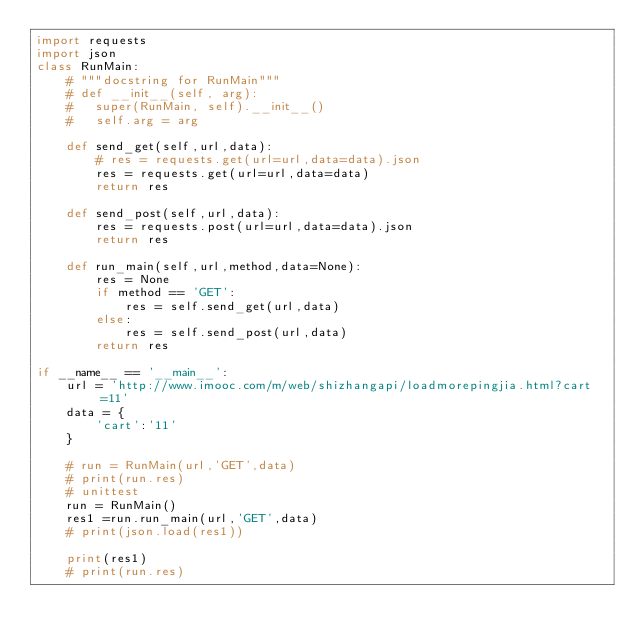Convert code to text. <code><loc_0><loc_0><loc_500><loc_500><_Python_>import requests
import json
class RunMain:
	# """docstring for RunMain"""
	# def __init__(self, arg):
	# 	super(RunMain, self).__init__()
	# 	self.arg = arg

	def send_get(self,url,data):
		# res = requests.get(url=url,data=data).json
		res = requests.get(url=url,data=data)
		return res

	def send_post(self,url,data):
		res = requests.post(url=url,data=data).json
		return res

	def run_main(self,url,method,data=None):
		res = None
		if method == 'GET':
			res = self.send_get(url,data)
		else:
			res = self.send_post(url,data)
		return res

if __name__ == '__main__':
	url = 'http://www.imooc.com/m/web/shizhangapi/loadmorepingjia.html?cart=11'
	data = {
		'cart':'11'
	}

	# run = RunMain(url,'GET',data)
	# print(run.res)
	# unittest
	run = RunMain()
	res1 =run.run_main(url,'GET',data)
	# print(json.load(res1))

	print(res1)
	# print(run.res)</code> 